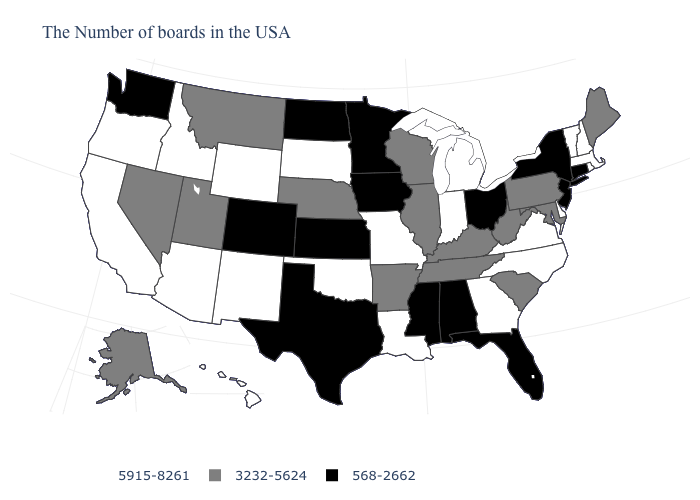What is the value of Nebraska?
Quick response, please. 3232-5624. How many symbols are there in the legend?
Give a very brief answer. 3. What is the value of Minnesota?
Keep it brief. 568-2662. What is the lowest value in the USA?
Concise answer only. 568-2662. Does Indiana have the highest value in the MidWest?
Give a very brief answer. Yes. Which states have the lowest value in the South?
Concise answer only. Florida, Alabama, Mississippi, Texas. Name the states that have a value in the range 5915-8261?
Keep it brief. Massachusetts, Rhode Island, New Hampshire, Vermont, Delaware, Virginia, North Carolina, Georgia, Michigan, Indiana, Louisiana, Missouri, Oklahoma, South Dakota, Wyoming, New Mexico, Arizona, Idaho, California, Oregon, Hawaii. Does Virginia have the highest value in the USA?
Quick response, please. Yes. Name the states that have a value in the range 5915-8261?
Concise answer only. Massachusetts, Rhode Island, New Hampshire, Vermont, Delaware, Virginia, North Carolina, Georgia, Michigan, Indiana, Louisiana, Missouri, Oklahoma, South Dakota, Wyoming, New Mexico, Arizona, Idaho, California, Oregon, Hawaii. Name the states that have a value in the range 568-2662?
Give a very brief answer. Connecticut, New York, New Jersey, Ohio, Florida, Alabama, Mississippi, Minnesota, Iowa, Kansas, Texas, North Dakota, Colorado, Washington. Name the states that have a value in the range 5915-8261?
Be succinct. Massachusetts, Rhode Island, New Hampshire, Vermont, Delaware, Virginia, North Carolina, Georgia, Michigan, Indiana, Louisiana, Missouri, Oklahoma, South Dakota, Wyoming, New Mexico, Arizona, Idaho, California, Oregon, Hawaii. Which states hav the highest value in the MidWest?
Keep it brief. Michigan, Indiana, Missouri, South Dakota. Name the states that have a value in the range 3232-5624?
Short answer required. Maine, Maryland, Pennsylvania, South Carolina, West Virginia, Kentucky, Tennessee, Wisconsin, Illinois, Arkansas, Nebraska, Utah, Montana, Nevada, Alaska. Does Arkansas have a lower value than North Carolina?
Quick response, please. Yes. 